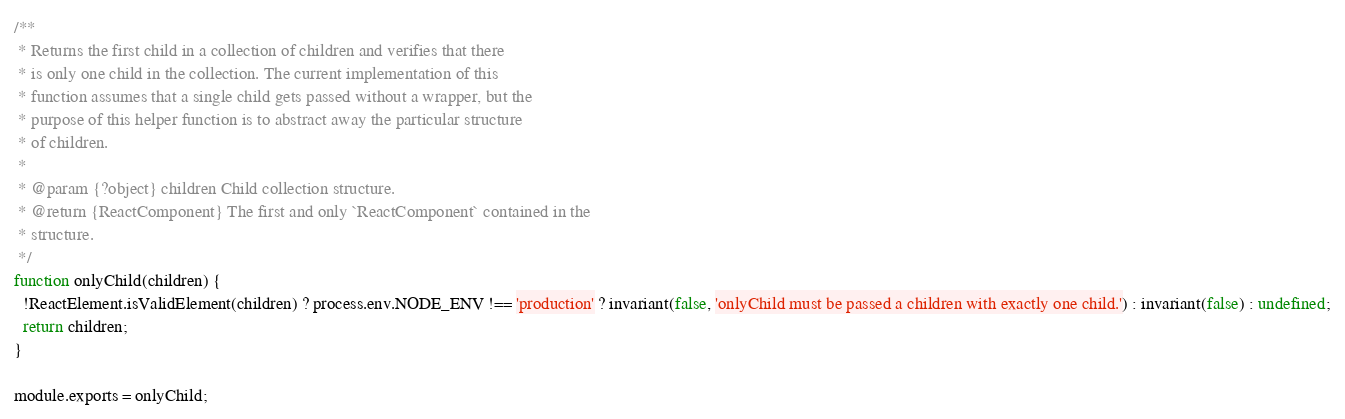Convert code to text. <code><loc_0><loc_0><loc_500><loc_500><_JavaScript_>/**
 * Returns the first child in a collection of children and verifies that there
 * is only one child in the collection. The current implementation of this
 * function assumes that a single child gets passed without a wrapper, but the
 * purpose of this helper function is to abstract away the particular structure
 * of children.
 *
 * @param {?object} children Child collection structure.
 * @return {ReactComponent} The first and only `ReactComponent` contained in the
 * structure.
 */
function onlyChild(children) {
  !ReactElement.isValidElement(children) ? process.env.NODE_ENV !== 'production' ? invariant(false, 'onlyChild must be passed a children with exactly one child.') : invariant(false) : undefined;
  return children;
}

module.exports = onlyChild;</code> 